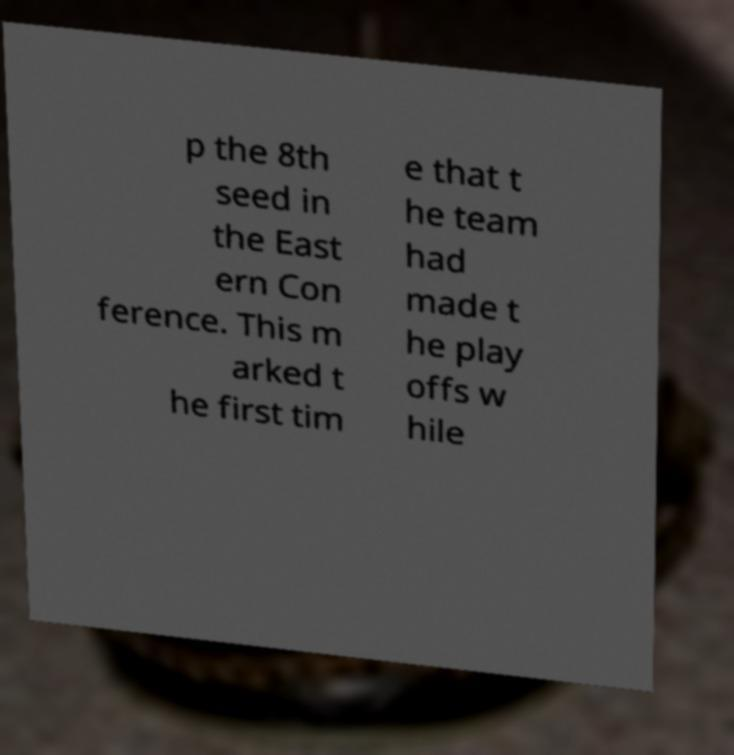Can you accurately transcribe the text from the provided image for me? p the 8th seed in the East ern Con ference. This m arked t he first tim e that t he team had made t he play offs w hile 